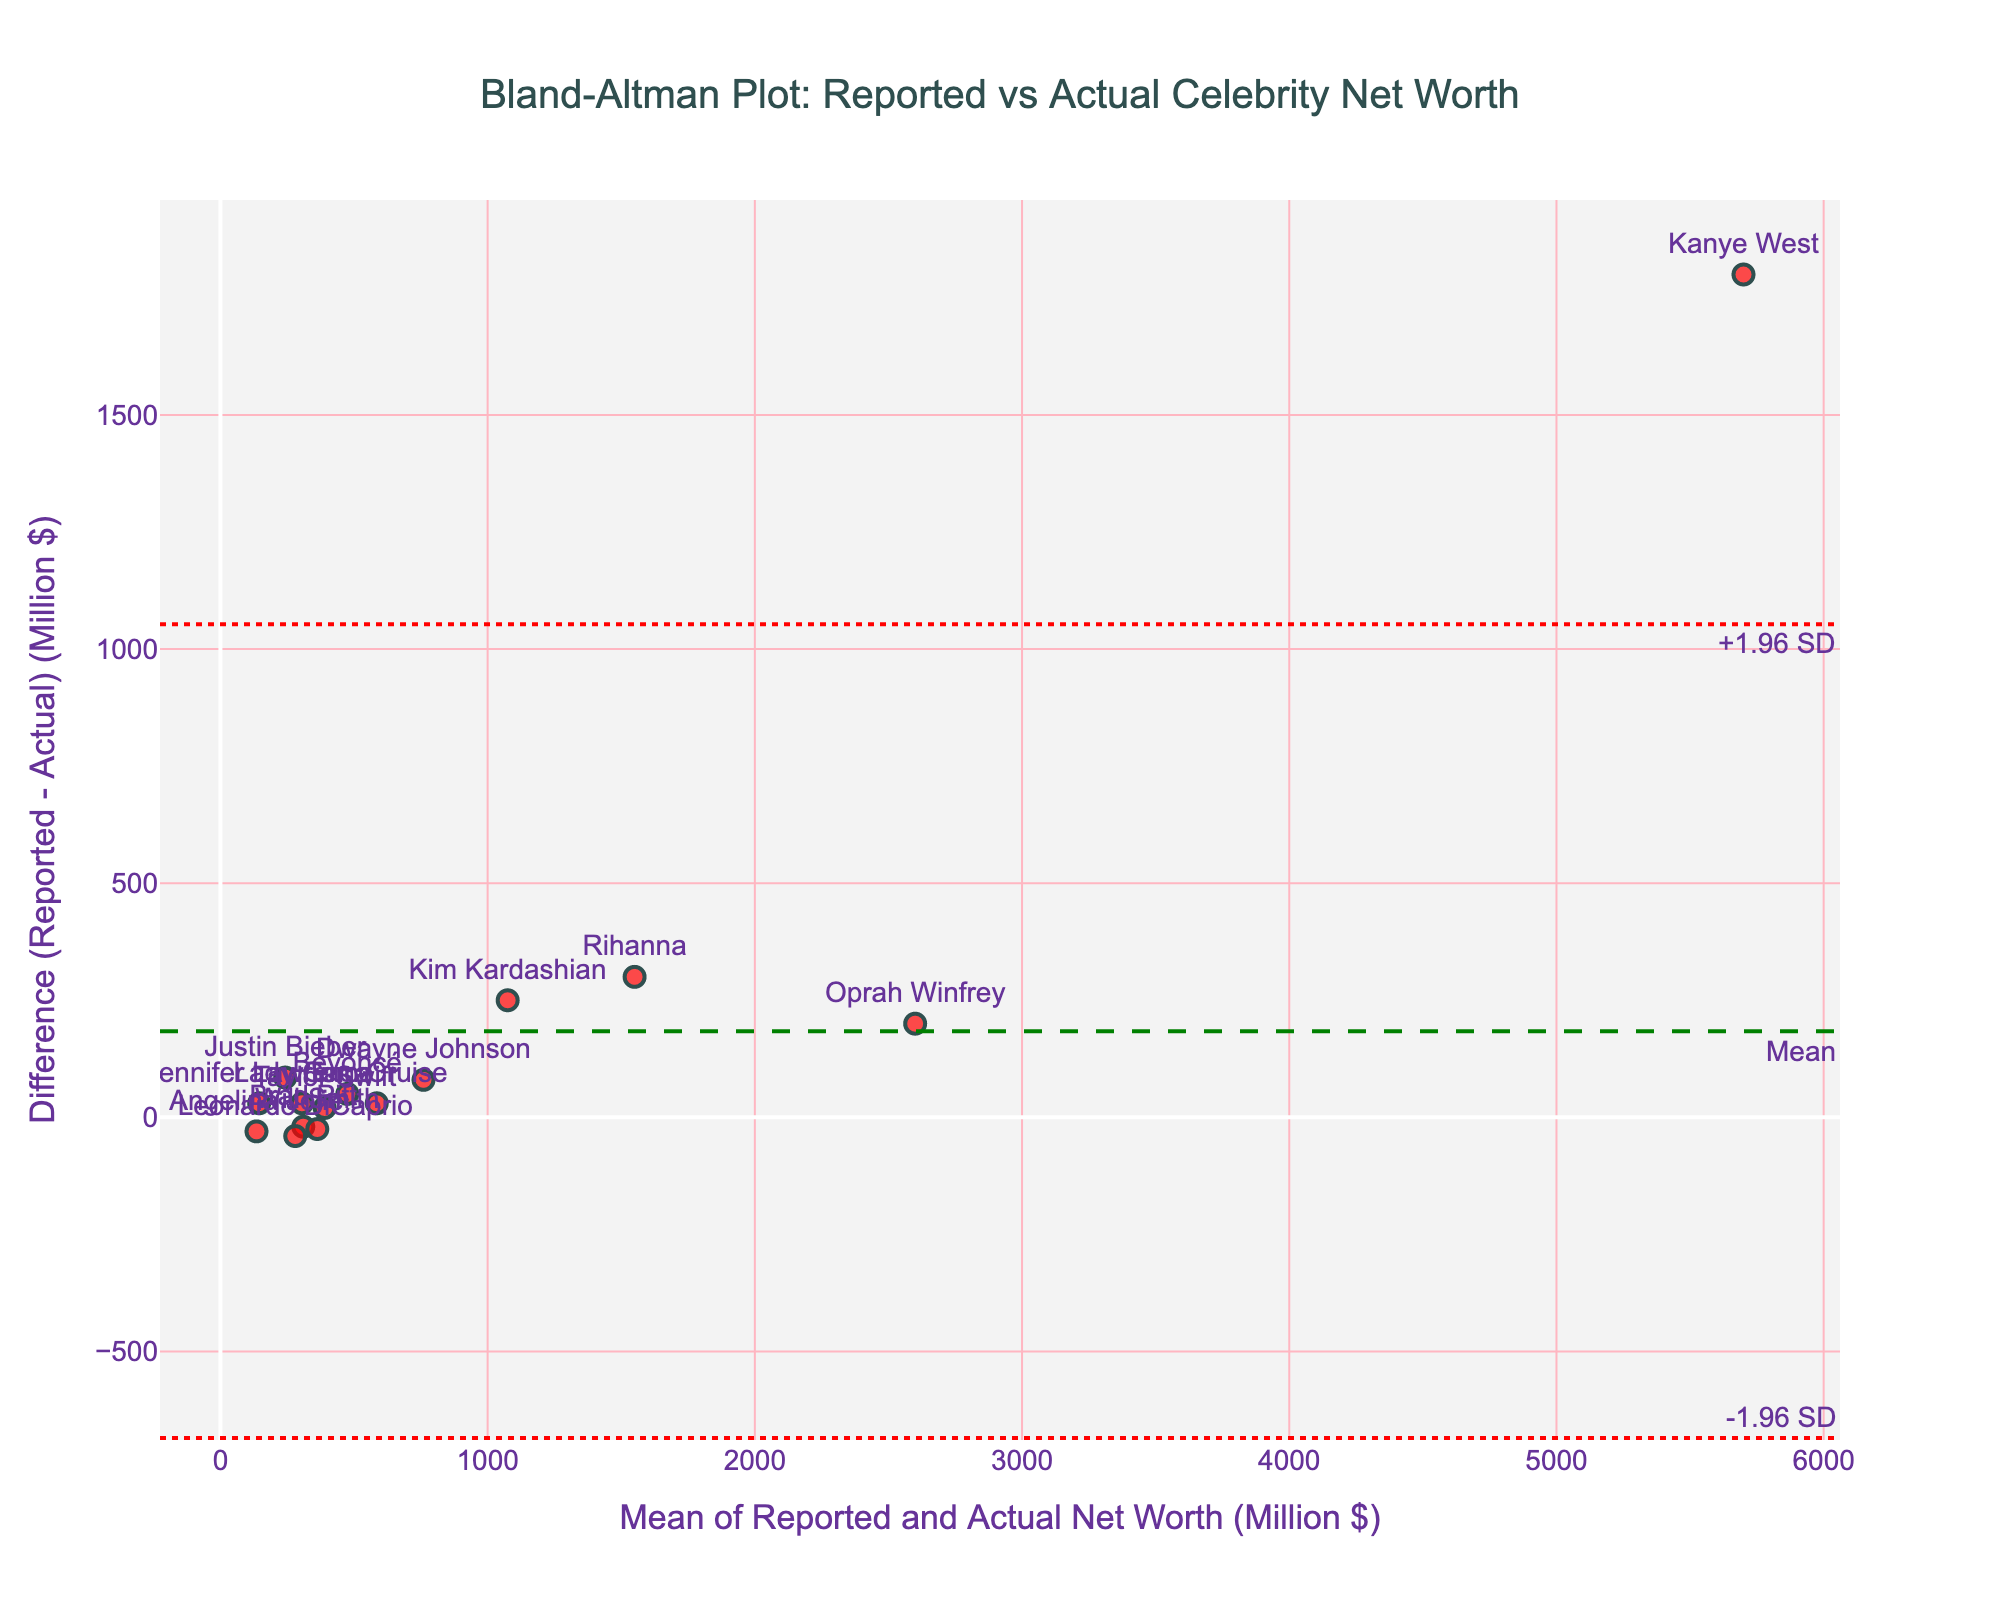what is the title of this figure? The title is displayed at the top center of the figure. It reads, "Bland-Altman Plot: Reported vs Actual Celebrity Net Worth" which clearly indicates that the plot shows a comparison between reported and actual net worths of celebrities.
Answer: Bland-Altman Plot: Reported vs Actual Celebrity Net Worth How many data points are represented in the plot? The plot includes each celebrity as a data point, and it will show a scatter plot with markers representing these data points. As per the dataset, there are 15 celebrities.
Answer: 15 What is the range of the x-axis? The x-axis title reads "Mean of Reported and Actual Net Worth (Million $)", and the range can be observed from the plot's edges. The lowest and highest values on the axis range approximately from 100 to 6000 million dollars.
Answer: Approximately 100 to 6000 million dollars Which celebrity has the largest difference between reported and actual net worth? The difference is visually the longest distance from the zero line on the y-axis in the plot. Kanye West has the largest difference, since his data point is farthest from the zero line.
Answer: Kanye West Is there a general trend where reported net worth is overestimated or underestimated compared to actual net worth? By observing the clustering of the data points above or below the zero line, we see there are more points above the zero line indicating that, generally, reported net worths are overestimated compared to actual net worths.
Answer: Overestimated What is the mean difference in net worths on this plot? The mean difference line is marked as "Mean" on the plot with green dash lines. This line visually indicates the mean difference value.
Answer: Mean difference is marked by a green dashed line Which two celebrities have reported net worths closest to their actual net worths? The closest points to the zero difference line on the y-axis are the ones where reported and actual net worths are almost equal. From the plot, the points closest to zero are for Taylor Swift and Will Smith.
Answer: Taylor Swift and Will Smith How wide are the limits of agreement on this plot? The limits of agreement are marked by "+1.96 SD" and "-1.96 SD" lines in red dot lines at the top and bottom respectively. The values span approximately from -400 to +800 million dollars; the difference between top and bottom limits can be calculated as approximately 1200 million dollars.
Answer: Approximately 1200 million dollars Name one celebrity who has an actual net worth higher than their reported net worth? The plot shows data points below the zero line, indicating instances where actual net worth exceeds reported net worth. Brad Pitt is one such celebrity.
Answer: Brad Pitt 